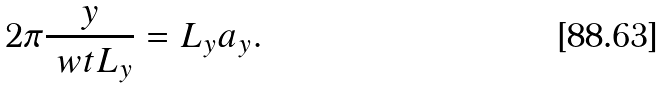<formula> <loc_0><loc_0><loc_500><loc_500>2 \pi \frac { y } { \ w t L _ { y } } = L _ { y } a _ { y } .</formula> 